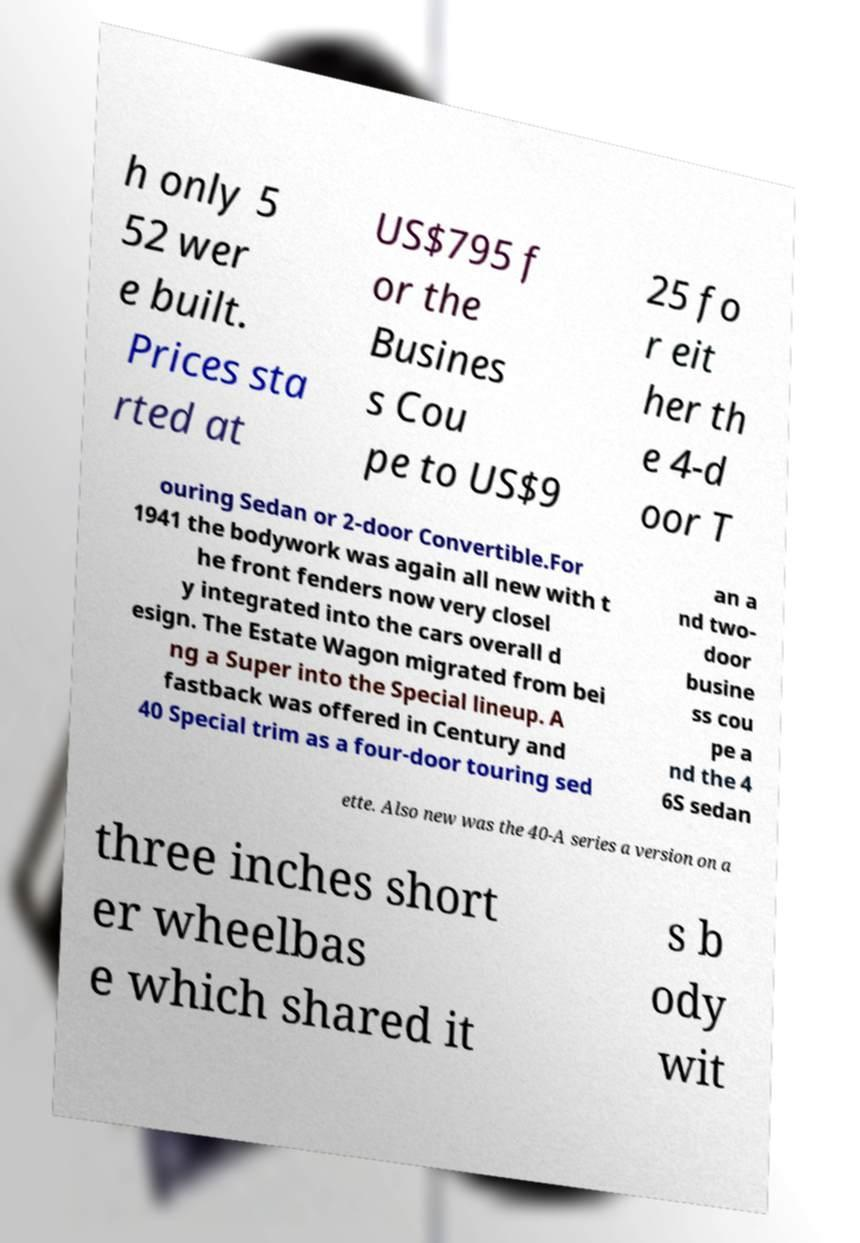Could you assist in decoding the text presented in this image and type it out clearly? h only 5 52 wer e built. Prices sta rted at US$795 f or the Busines s Cou pe to US$9 25 fo r eit her th e 4-d oor T ouring Sedan or 2-door Convertible.For 1941 the bodywork was again all new with t he front fenders now very closel y integrated into the cars overall d esign. The Estate Wagon migrated from bei ng a Super into the Special lineup. A fastback was offered in Century and 40 Special trim as a four-door touring sed an a nd two- door busine ss cou pe a nd the 4 6S sedan ette. Also new was the 40-A series a version on a three inches short er wheelbas e which shared it s b ody wit 